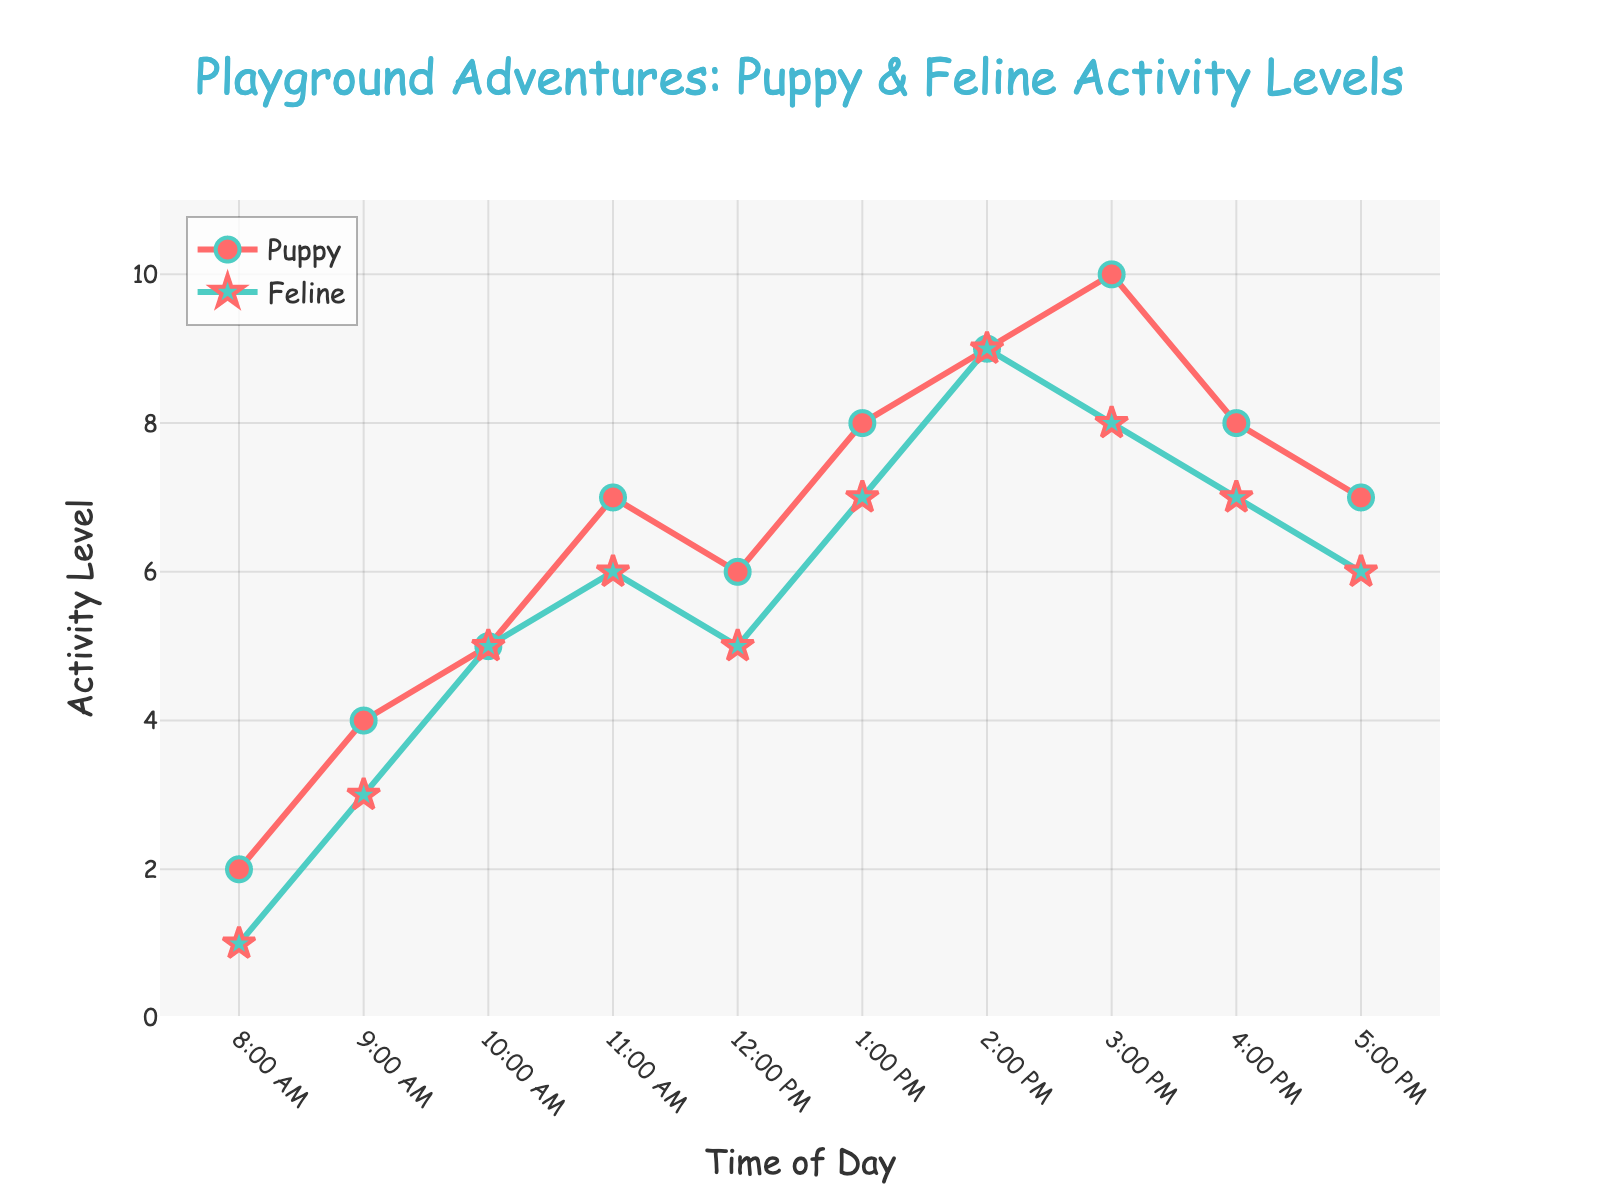What is the title of the plot? The title is prominently displayed at the top of the plot in a larger, colorful font.
Answer: Playground Adventures: Puppy & Feline Activity Levels At what time of day does the puppy reach its maximum activity level? By examining the plot, the highest point on the puppy's line occurs at 3:00 PM with an activity level of 10.
Answer: 3:00 PM Does the feline's activity level ever reach 9? Look for the points along the feline's line plot. The feline's activity level reaches 9 at 2:00 PM.
Answer: Yes What is the activity level of the puppy at 10:00 AM? Locate the point corresponding to 10:00 AM on the puppy's line, which is positioned at an activity level of 5.
Answer: 5 What time of day shows the least activity for both the puppy and the feline? Compare the activity levels across the timeline for both animals. Both have the least activity at 8:00 AM, with activity levels of 2 for the puppy and 1 for the feline.
Answer: 8:00 AM How much does the feline's activity level increase from 8:00 AM to 9:00 AM? The feline's activity level at 8:00 AM is 1, and at 9:00 AM, it is 3. Subtract 1 from 3 to find the increase.
Answer: 2 What time of day do the puppy and the feline have the same activity level? Look for points where the lines or markers for both animals coincide. At 10:00 AM, both the puppy and feline have an activity level of 5.
Answer: 10:00 AM Which animal reaches a maximum activity level first, and at what time? Compare the highest points for each animal. The feline reaches a maximum activity level of 9 at 2:00 PM, followed by the puppy reaching a maximum of 10 at 3:00 PM.
Answer: Feline, 2:00 PM How does the activity level of the puppy change from 2:00 PM to 4:00 PM? The activity level of the puppy at 2:00 PM is 9, at 3:00 PM it is 10, and at 4:00 PM it decreases to 8. The puppy's activity level increases from 9 to 10 and then drops to 8.
Answer: Increases then decreases What is the average activity level of the puppy at noon and 1:00 PM? Add the puppy’s activity levels at 12:00 PM (6) and 1:00 PM (8) and divide by 2. (6 + 8) / 2 = 7
Answer: 7 